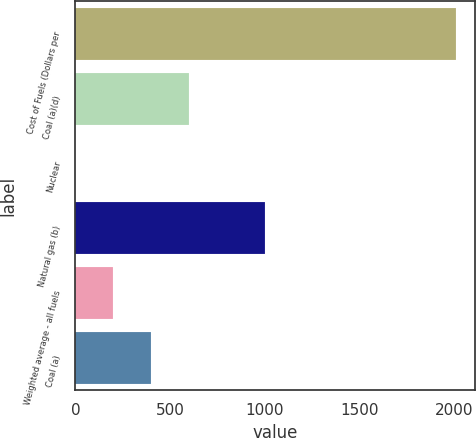<chart> <loc_0><loc_0><loc_500><loc_500><bar_chart><fcel>Cost of Fuels (Dollars per<fcel>Coal (a)(d)<fcel>Nuclear<fcel>Natural gas (b)<fcel>Weighted average - all fuels<fcel>Coal (a)<nl><fcel>2007<fcel>602.44<fcel>0.49<fcel>1003.74<fcel>201.14<fcel>401.79<nl></chart> 